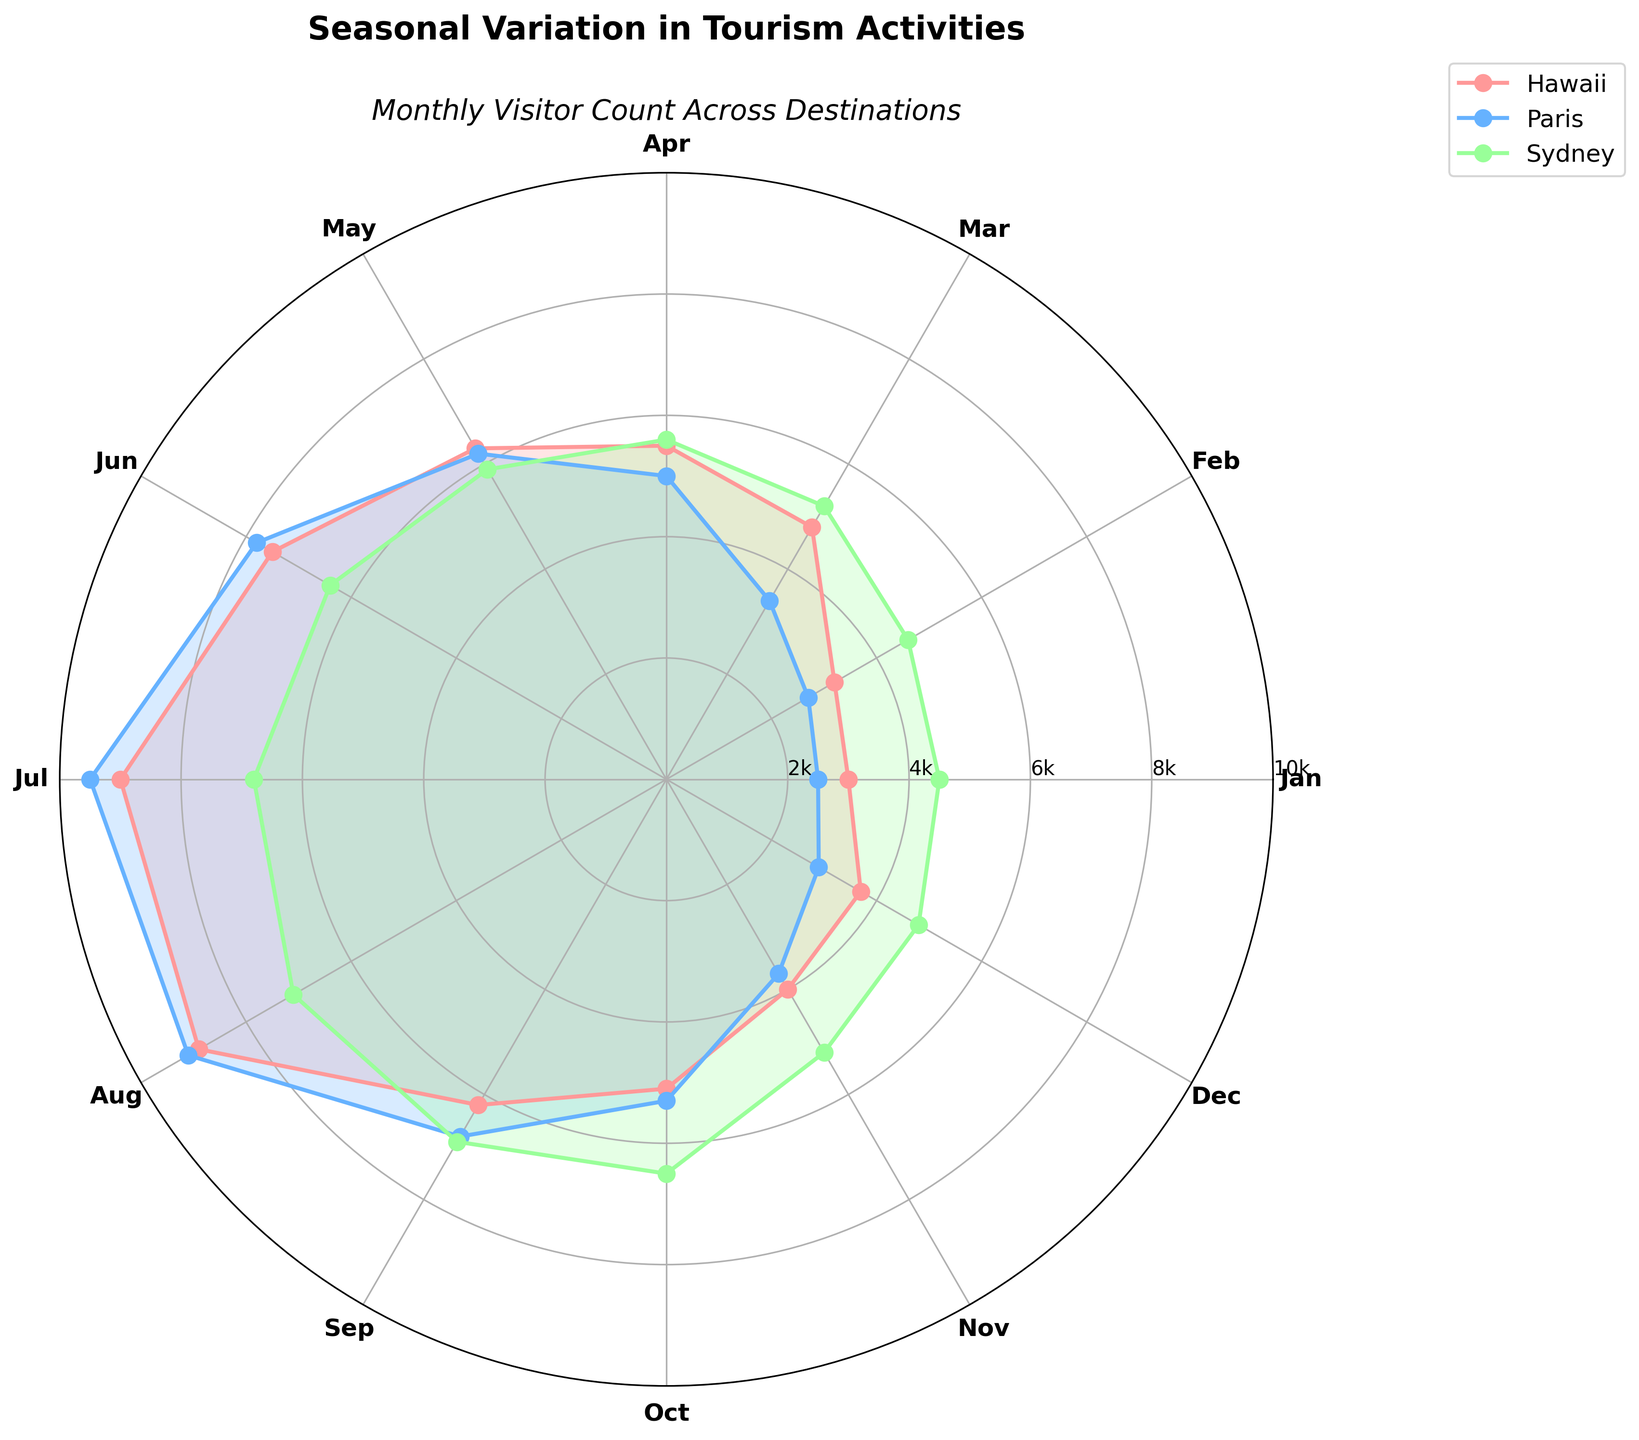Which month had the highest number of visitors in Hawaii? To find the month with the highest number of visitors in Hawaii, we look for the peak in the plot line for Hawaii. The peak appears in July.
Answer: July What's the average number of visitors in Paris over the year? To calculate the average number of visitors in Paris, sum all the visitors for each month and then divide by the number of months (12). So, it's (2500 + 2700 + 3400 + 5000 + 6200 + 7800 + 9500 + 9100 + 6800 + 5300 + 3700 + 2900)/12 = 5500.
Answer: 5500 During which months does Sydney see a steady increase in the number of visitors? By observing the plot for Sydney, we notice that the visitor count steadily increases from January to August.
Answer: January to August Which destination has the most visitors in December? Comparing the polar chart for all destinations in December, the highest number of visitors is for Sydney.
Answer: Sydney How do the seasonal trends of Paris and Hawaii compare across the year? To compare the seasonal trends, observe the plot lines for both Paris and Hawaii. Paris sees a steady increase in visitors from January, peaking in July and August, then declining. Hawaii shows a similar pattern but remains relatively lower in the winter months and peaks in July. Both have a summer peak but Paris has higher summer visitors overall.
Answer: Both have a summer peak, but Paris has higher visitors in the summer What is the difference in the number of visitors between July and December in Hawaii? To find this, subtract the number of visitors in December (3700) from the visitors in July (9000). 9000 - 3700 = 5300.
Answer: 5300 Which month has the least variation in the number of visitors among the three destinations? By visually inspecting the plot, December appears to show the least variation as all lines are relatively close together.
Answer: December Are there any months where all destinations have a decline in the number of visitors compared to the previous month? By examining the plot, we can see that all destinations show a drop in visitor numbers from October to November.
Answer: October to November What's the biggest jump in visitor numbers for Sydney in any two consecutive months? Looking at the Sydney plot, the biggest jump is from May to June, from around 5900 to 6400, an increase of 500.
Answer: 500 How does the range of visitors for each destination differ? The range is the difference between the highest and lowest number of visitors for each destination. For Hawaii, the range is 9000 - 3000 = 6000. For Paris, the range is 9500 - 2500 = 7000. For Sydney, the range is 7100 - 4500 = 2600.
Answer: Hawaii: 6000, Paris: 7000, Sydney: 2600 